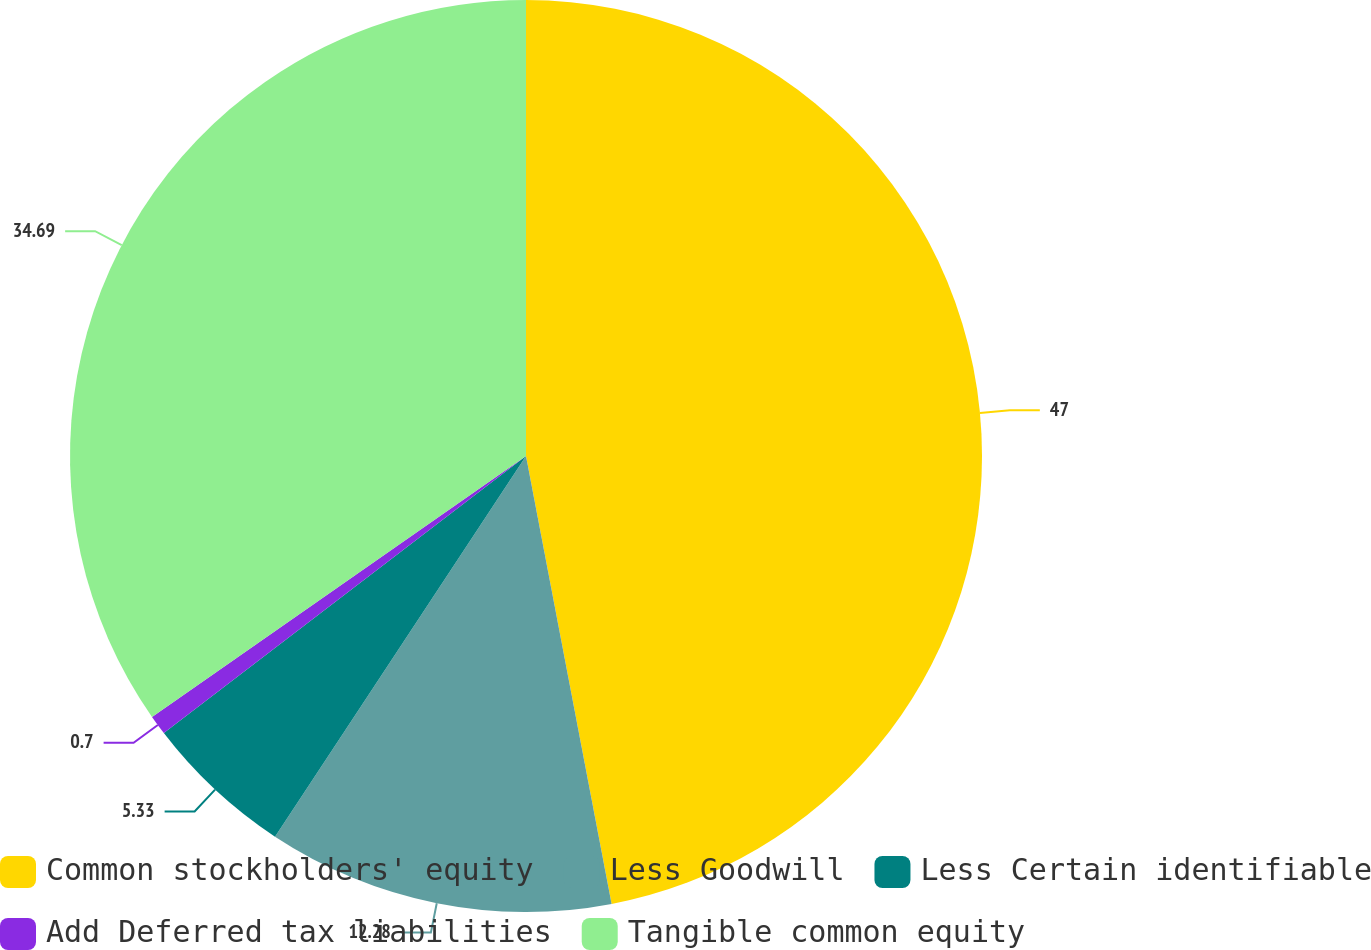<chart> <loc_0><loc_0><loc_500><loc_500><pie_chart><fcel>Common stockholders' equity<fcel>Less Goodwill<fcel>Less Certain identifiable<fcel>Add Deferred tax liabilities<fcel>Tangible common equity<nl><fcel>46.99%<fcel>12.28%<fcel>5.33%<fcel>0.7%<fcel>34.69%<nl></chart> 